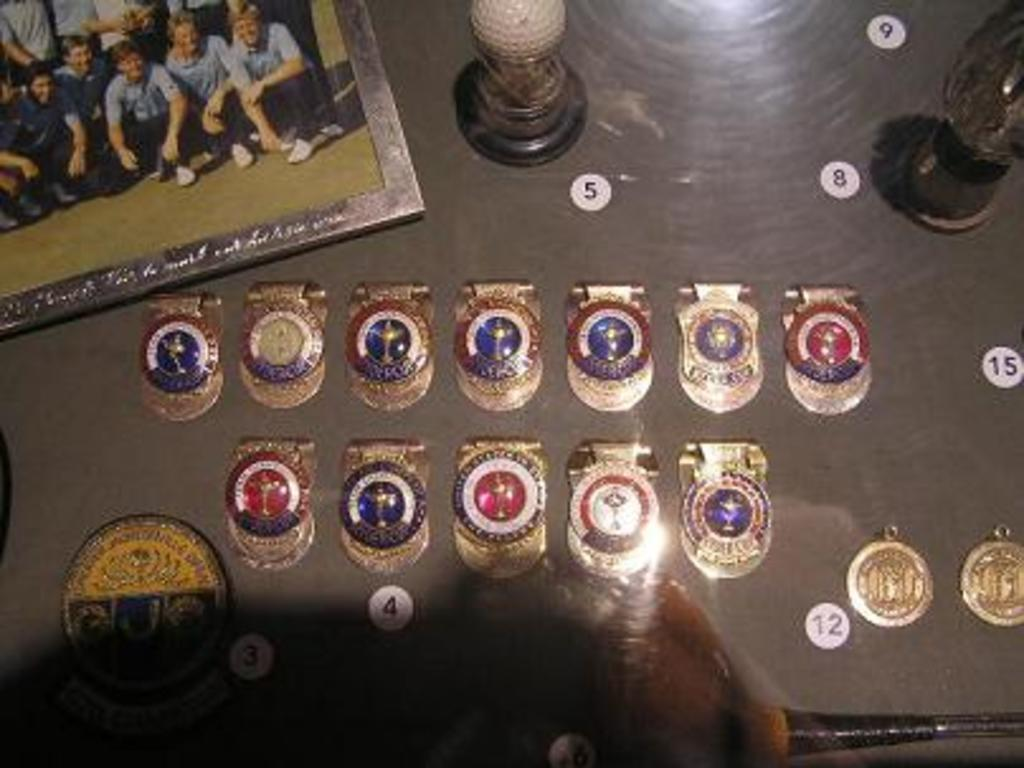<image>
Write a terse but informative summary of the picture. Several gold medals with various red, white, and blue accents surrounded by numbered labels including 3, 4, 5, 8, 9, 12, and 15 